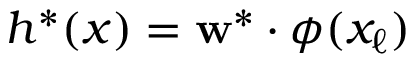<formula> <loc_0><loc_0><loc_500><loc_500>h ^ { * } ( x ) = w ^ { * } \cdot \phi ( x _ { \ell } )</formula> 